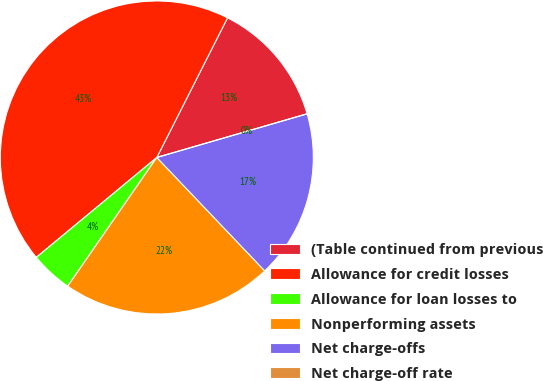Convert chart to OTSL. <chart><loc_0><loc_0><loc_500><loc_500><pie_chart><fcel>(Table continued from previous<fcel>Allowance for credit losses<fcel>Allowance for loan losses to<fcel>Nonperforming assets<fcel>Net charge-offs<fcel>Net charge-off rate<nl><fcel>13.04%<fcel>43.47%<fcel>4.35%<fcel>21.74%<fcel>17.39%<fcel>0.0%<nl></chart> 